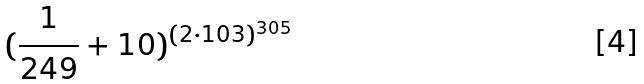Convert formula to latex. <formula><loc_0><loc_0><loc_500><loc_500>( \frac { 1 } { 2 4 9 } + 1 0 ) ^ { ( 2 \cdot 1 0 3 ) ^ { 3 0 5 } }</formula> 